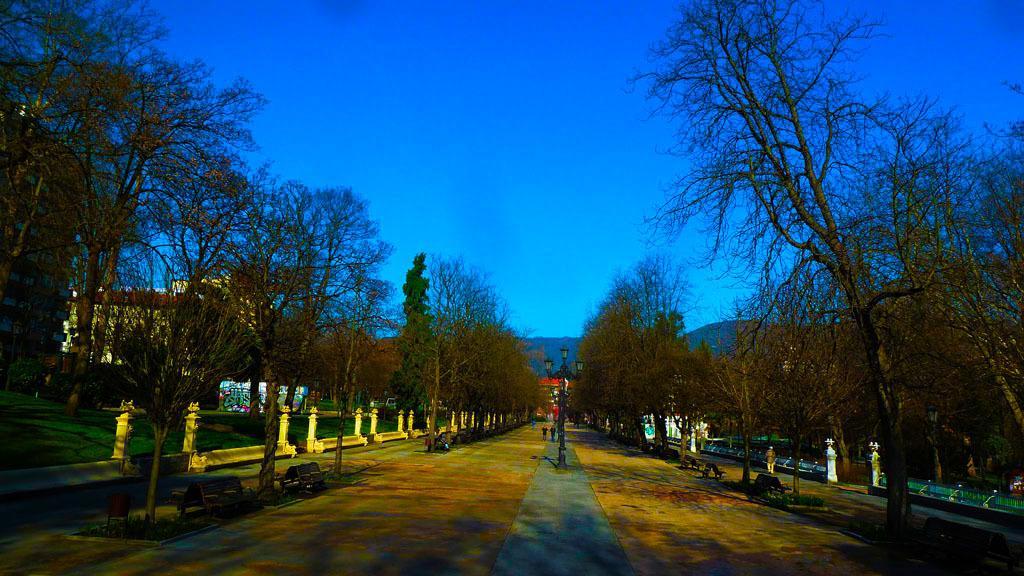Could you give a brief overview of what you see in this image? In the picture we can see a street with a pathway and in the middle of the pathway we can see the poles with lights to it and besides the path we can see some trees and behind it, we can see a grass surface and in the background we can see a house and behind it we can see hills and sky. 